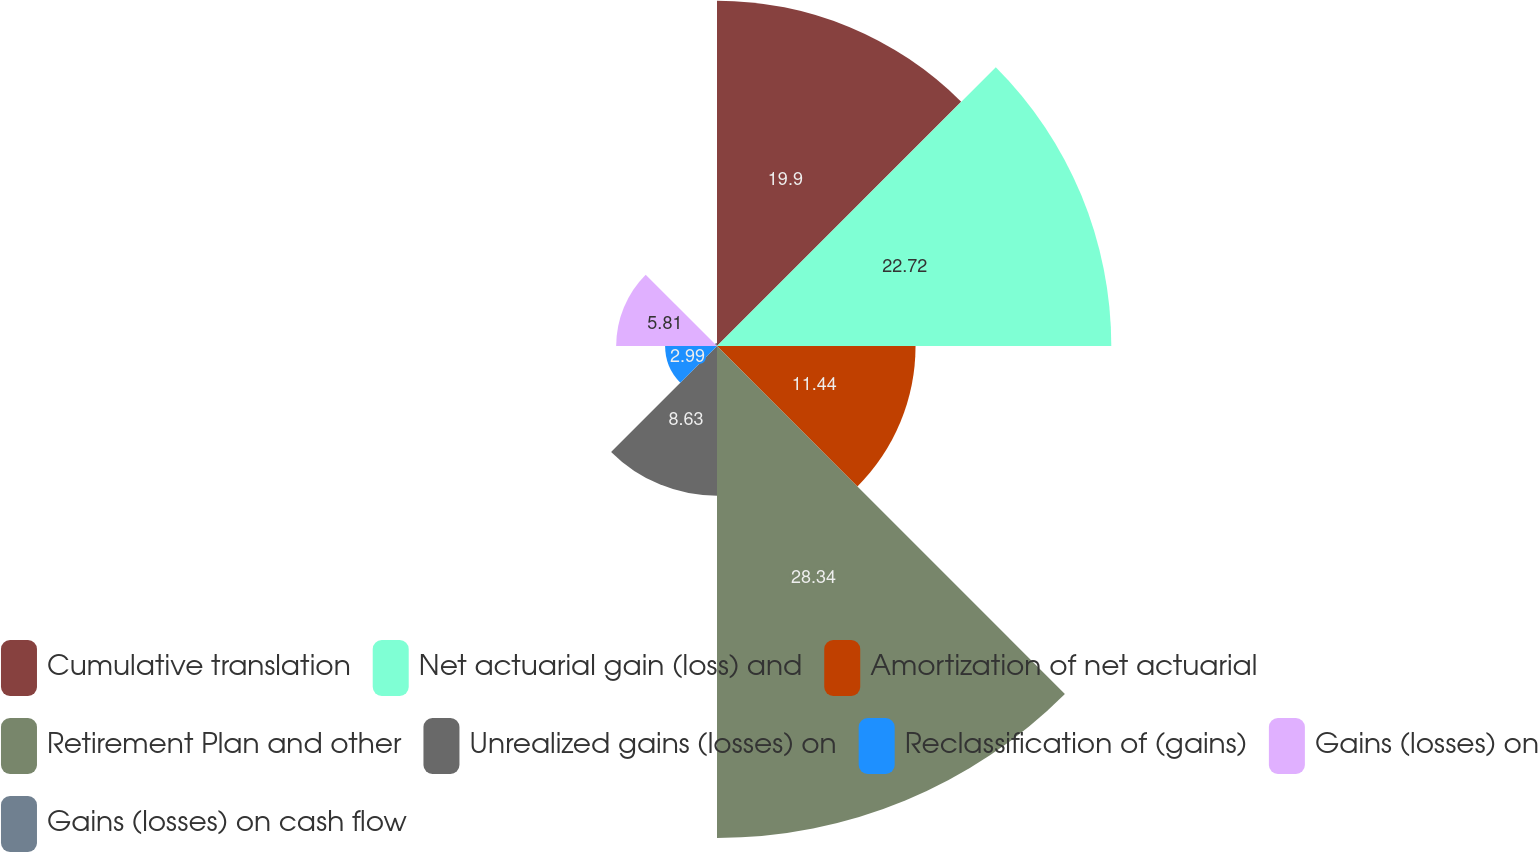Convert chart to OTSL. <chart><loc_0><loc_0><loc_500><loc_500><pie_chart><fcel>Cumulative translation<fcel>Net actuarial gain (loss) and<fcel>Amortization of net actuarial<fcel>Retirement Plan and other<fcel>Unrealized gains (losses) on<fcel>Reclassification of (gains)<fcel>Gains (losses) on<fcel>Gains (losses) on cash flow<nl><fcel>19.9%<fcel>22.72%<fcel>11.44%<fcel>28.35%<fcel>8.63%<fcel>2.99%<fcel>5.81%<fcel>0.17%<nl></chart> 